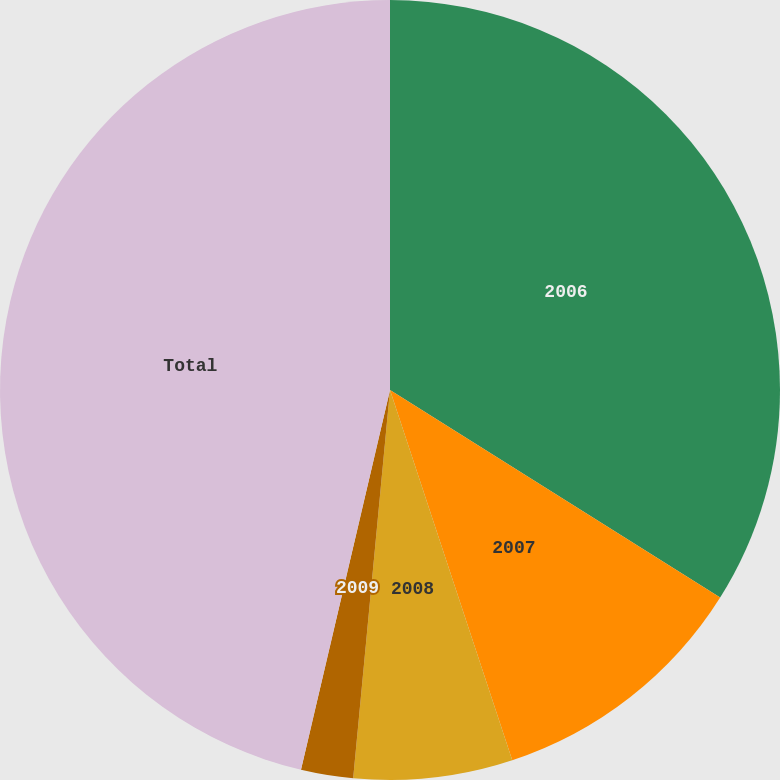Convert chart to OTSL. <chart><loc_0><loc_0><loc_500><loc_500><pie_chart><fcel>2006<fcel>2007<fcel>2008<fcel>2009<fcel>Total<nl><fcel>33.93%<fcel>10.99%<fcel>6.58%<fcel>2.16%<fcel>46.33%<nl></chart> 